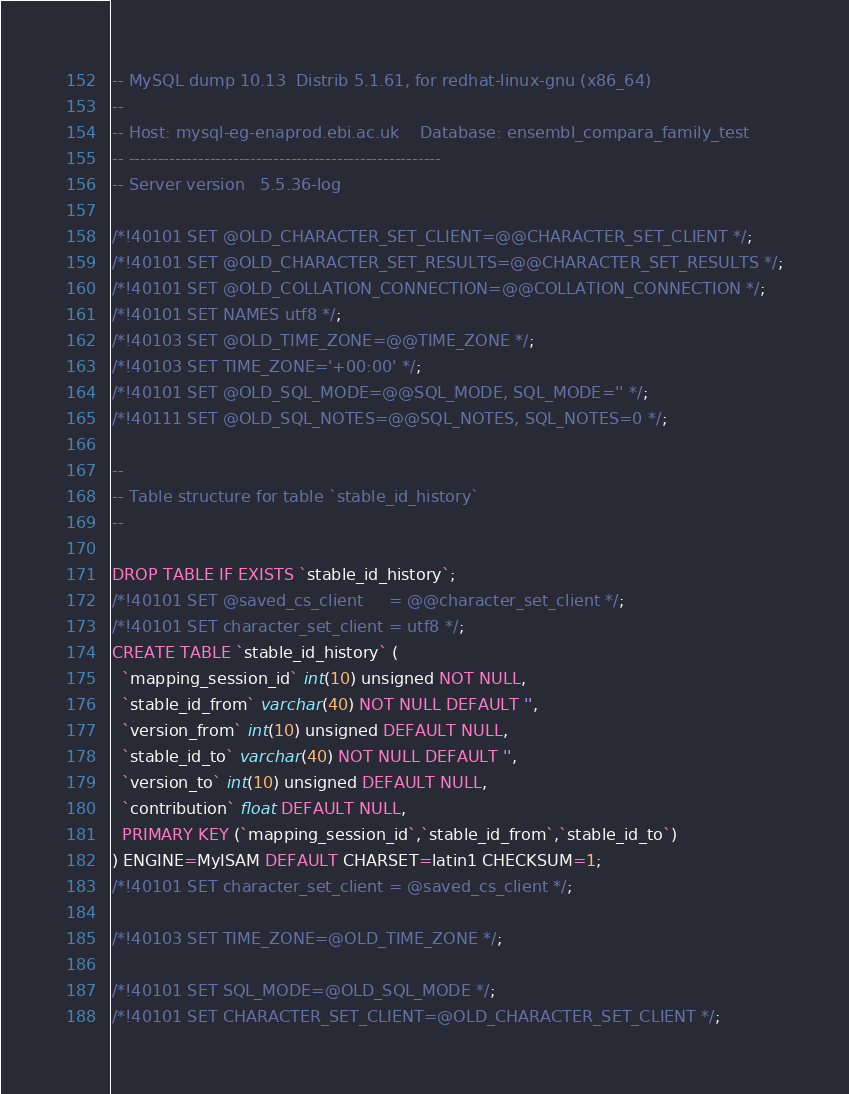<code> <loc_0><loc_0><loc_500><loc_500><_SQL_>-- MySQL dump 10.13  Distrib 5.1.61, for redhat-linux-gnu (x86_64)
--
-- Host: mysql-eg-enaprod.ebi.ac.uk    Database: ensembl_compara_family_test
-- ------------------------------------------------------
-- Server version	5.5.36-log

/*!40101 SET @OLD_CHARACTER_SET_CLIENT=@@CHARACTER_SET_CLIENT */;
/*!40101 SET @OLD_CHARACTER_SET_RESULTS=@@CHARACTER_SET_RESULTS */;
/*!40101 SET @OLD_COLLATION_CONNECTION=@@COLLATION_CONNECTION */;
/*!40101 SET NAMES utf8 */;
/*!40103 SET @OLD_TIME_ZONE=@@TIME_ZONE */;
/*!40103 SET TIME_ZONE='+00:00' */;
/*!40101 SET @OLD_SQL_MODE=@@SQL_MODE, SQL_MODE='' */;
/*!40111 SET @OLD_SQL_NOTES=@@SQL_NOTES, SQL_NOTES=0 */;

--
-- Table structure for table `stable_id_history`
--

DROP TABLE IF EXISTS `stable_id_history`;
/*!40101 SET @saved_cs_client     = @@character_set_client */;
/*!40101 SET character_set_client = utf8 */;
CREATE TABLE `stable_id_history` (
  `mapping_session_id` int(10) unsigned NOT NULL,
  `stable_id_from` varchar(40) NOT NULL DEFAULT '',
  `version_from` int(10) unsigned DEFAULT NULL,
  `stable_id_to` varchar(40) NOT NULL DEFAULT '',
  `version_to` int(10) unsigned DEFAULT NULL,
  `contribution` float DEFAULT NULL,
  PRIMARY KEY (`mapping_session_id`,`stable_id_from`,`stable_id_to`)
) ENGINE=MyISAM DEFAULT CHARSET=latin1 CHECKSUM=1;
/*!40101 SET character_set_client = @saved_cs_client */;

/*!40103 SET TIME_ZONE=@OLD_TIME_ZONE */;

/*!40101 SET SQL_MODE=@OLD_SQL_MODE */;
/*!40101 SET CHARACTER_SET_CLIENT=@OLD_CHARACTER_SET_CLIENT */;</code> 